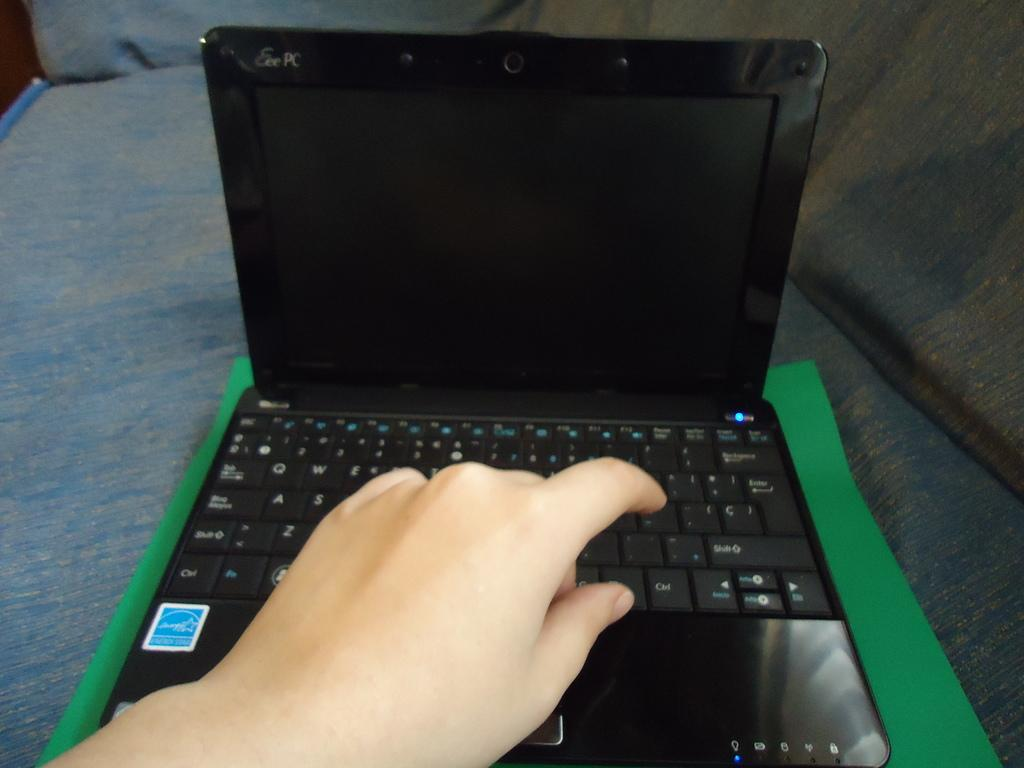<image>
Present a compact description of the photo's key features. An Eee PC laptop is open, but has a blank screen. 